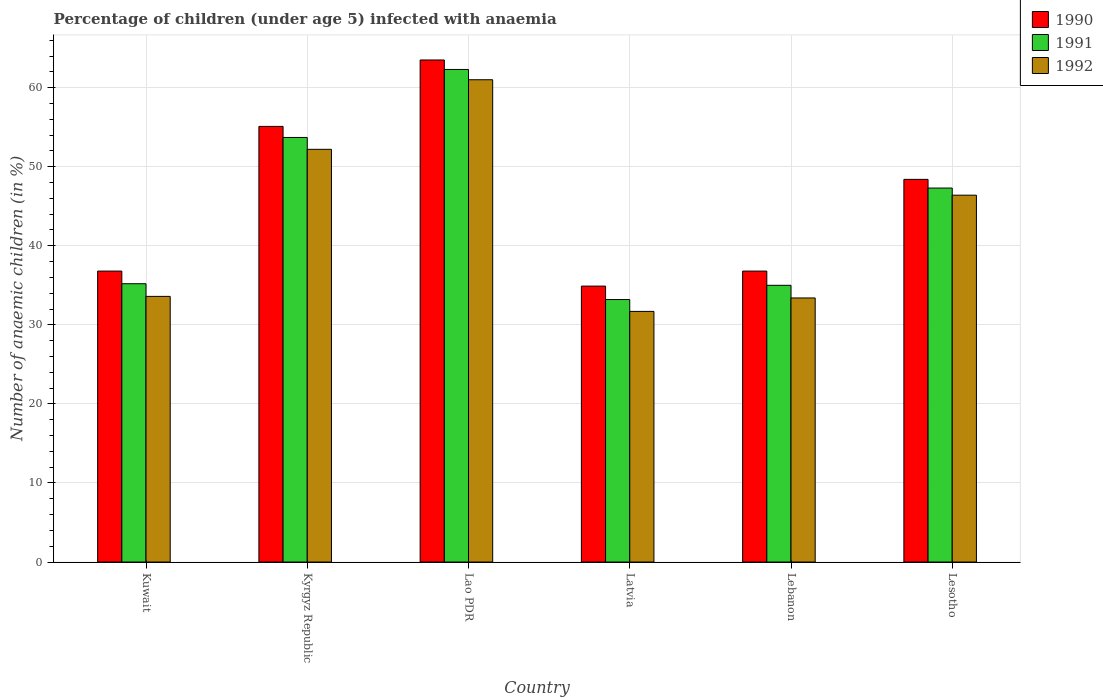Are the number of bars per tick equal to the number of legend labels?
Offer a very short reply. Yes. Are the number of bars on each tick of the X-axis equal?
Offer a terse response. Yes. How many bars are there on the 6th tick from the right?
Your response must be concise. 3. What is the label of the 3rd group of bars from the left?
Make the answer very short. Lao PDR. What is the percentage of children infected with anaemia in in 1991 in Lesotho?
Your response must be concise. 47.3. Across all countries, what is the maximum percentage of children infected with anaemia in in 1991?
Provide a short and direct response. 62.3. Across all countries, what is the minimum percentage of children infected with anaemia in in 1992?
Provide a short and direct response. 31.7. In which country was the percentage of children infected with anaemia in in 1990 maximum?
Keep it short and to the point. Lao PDR. In which country was the percentage of children infected with anaemia in in 1992 minimum?
Offer a very short reply. Latvia. What is the total percentage of children infected with anaemia in in 1990 in the graph?
Keep it short and to the point. 275.5. What is the difference between the percentage of children infected with anaemia in in 1990 in Kuwait and that in Kyrgyz Republic?
Give a very brief answer. -18.3. What is the difference between the percentage of children infected with anaemia in in 1990 in Kyrgyz Republic and the percentage of children infected with anaemia in in 1992 in Lao PDR?
Your response must be concise. -5.9. What is the average percentage of children infected with anaemia in in 1992 per country?
Offer a very short reply. 43.05. What is the difference between the percentage of children infected with anaemia in of/in 1990 and percentage of children infected with anaemia in of/in 1991 in Lao PDR?
Your answer should be compact. 1.2. What is the ratio of the percentage of children infected with anaemia in in 1990 in Kyrgyz Republic to that in Latvia?
Your answer should be very brief. 1.58. Is the percentage of children infected with anaemia in in 1990 in Lebanon less than that in Lesotho?
Provide a succinct answer. Yes. Is the difference between the percentage of children infected with anaemia in in 1990 in Kuwait and Lesotho greater than the difference between the percentage of children infected with anaemia in in 1991 in Kuwait and Lesotho?
Keep it short and to the point. Yes. What is the difference between the highest and the second highest percentage of children infected with anaemia in in 1992?
Provide a succinct answer. -8.8. What is the difference between the highest and the lowest percentage of children infected with anaemia in in 1990?
Make the answer very short. 28.6. What does the 1st bar from the right in Lao PDR represents?
Offer a terse response. 1992. Is it the case that in every country, the sum of the percentage of children infected with anaemia in in 1990 and percentage of children infected with anaemia in in 1991 is greater than the percentage of children infected with anaemia in in 1992?
Make the answer very short. Yes. Are all the bars in the graph horizontal?
Ensure brevity in your answer.  No. How many countries are there in the graph?
Your answer should be compact. 6. What is the difference between two consecutive major ticks on the Y-axis?
Your answer should be compact. 10. How many legend labels are there?
Your answer should be compact. 3. What is the title of the graph?
Keep it short and to the point. Percentage of children (under age 5) infected with anaemia. Does "1960" appear as one of the legend labels in the graph?
Provide a short and direct response. No. What is the label or title of the Y-axis?
Make the answer very short. Number of anaemic children (in %). What is the Number of anaemic children (in %) in 1990 in Kuwait?
Offer a very short reply. 36.8. What is the Number of anaemic children (in %) in 1991 in Kuwait?
Offer a very short reply. 35.2. What is the Number of anaemic children (in %) of 1992 in Kuwait?
Give a very brief answer. 33.6. What is the Number of anaemic children (in %) in 1990 in Kyrgyz Republic?
Make the answer very short. 55.1. What is the Number of anaemic children (in %) of 1991 in Kyrgyz Republic?
Offer a very short reply. 53.7. What is the Number of anaemic children (in %) in 1992 in Kyrgyz Republic?
Ensure brevity in your answer.  52.2. What is the Number of anaemic children (in %) of 1990 in Lao PDR?
Provide a short and direct response. 63.5. What is the Number of anaemic children (in %) in 1991 in Lao PDR?
Offer a very short reply. 62.3. What is the Number of anaemic children (in %) in 1990 in Latvia?
Give a very brief answer. 34.9. What is the Number of anaemic children (in %) of 1991 in Latvia?
Your response must be concise. 33.2. What is the Number of anaemic children (in %) in 1992 in Latvia?
Your answer should be very brief. 31.7. What is the Number of anaemic children (in %) in 1990 in Lebanon?
Ensure brevity in your answer.  36.8. What is the Number of anaemic children (in %) of 1992 in Lebanon?
Ensure brevity in your answer.  33.4. What is the Number of anaemic children (in %) in 1990 in Lesotho?
Your response must be concise. 48.4. What is the Number of anaemic children (in %) in 1991 in Lesotho?
Your response must be concise. 47.3. What is the Number of anaemic children (in %) in 1992 in Lesotho?
Keep it short and to the point. 46.4. Across all countries, what is the maximum Number of anaemic children (in %) of 1990?
Keep it short and to the point. 63.5. Across all countries, what is the maximum Number of anaemic children (in %) of 1991?
Make the answer very short. 62.3. Across all countries, what is the maximum Number of anaemic children (in %) of 1992?
Provide a succinct answer. 61. Across all countries, what is the minimum Number of anaemic children (in %) of 1990?
Provide a succinct answer. 34.9. Across all countries, what is the minimum Number of anaemic children (in %) in 1991?
Offer a very short reply. 33.2. Across all countries, what is the minimum Number of anaemic children (in %) of 1992?
Offer a very short reply. 31.7. What is the total Number of anaemic children (in %) in 1990 in the graph?
Make the answer very short. 275.5. What is the total Number of anaemic children (in %) in 1991 in the graph?
Ensure brevity in your answer.  266.7. What is the total Number of anaemic children (in %) in 1992 in the graph?
Ensure brevity in your answer.  258.3. What is the difference between the Number of anaemic children (in %) in 1990 in Kuwait and that in Kyrgyz Republic?
Give a very brief answer. -18.3. What is the difference between the Number of anaemic children (in %) of 1991 in Kuwait and that in Kyrgyz Republic?
Ensure brevity in your answer.  -18.5. What is the difference between the Number of anaemic children (in %) in 1992 in Kuwait and that in Kyrgyz Republic?
Your answer should be very brief. -18.6. What is the difference between the Number of anaemic children (in %) of 1990 in Kuwait and that in Lao PDR?
Your answer should be very brief. -26.7. What is the difference between the Number of anaemic children (in %) of 1991 in Kuwait and that in Lao PDR?
Provide a succinct answer. -27.1. What is the difference between the Number of anaemic children (in %) in 1992 in Kuwait and that in Lao PDR?
Provide a succinct answer. -27.4. What is the difference between the Number of anaemic children (in %) of 1991 in Kuwait and that in Latvia?
Make the answer very short. 2. What is the difference between the Number of anaemic children (in %) of 1992 in Kuwait and that in Latvia?
Give a very brief answer. 1.9. What is the difference between the Number of anaemic children (in %) of 1990 in Kuwait and that in Lesotho?
Provide a succinct answer. -11.6. What is the difference between the Number of anaemic children (in %) of 1991 in Kyrgyz Republic and that in Lao PDR?
Your response must be concise. -8.6. What is the difference between the Number of anaemic children (in %) in 1992 in Kyrgyz Republic and that in Lao PDR?
Keep it short and to the point. -8.8. What is the difference between the Number of anaemic children (in %) in 1990 in Kyrgyz Republic and that in Latvia?
Give a very brief answer. 20.2. What is the difference between the Number of anaemic children (in %) of 1990 in Kyrgyz Republic and that in Lebanon?
Make the answer very short. 18.3. What is the difference between the Number of anaemic children (in %) in 1991 in Kyrgyz Republic and that in Lebanon?
Your response must be concise. 18.7. What is the difference between the Number of anaemic children (in %) of 1990 in Kyrgyz Republic and that in Lesotho?
Your answer should be very brief. 6.7. What is the difference between the Number of anaemic children (in %) of 1991 in Kyrgyz Republic and that in Lesotho?
Make the answer very short. 6.4. What is the difference between the Number of anaemic children (in %) of 1990 in Lao PDR and that in Latvia?
Your response must be concise. 28.6. What is the difference between the Number of anaemic children (in %) of 1991 in Lao PDR and that in Latvia?
Give a very brief answer. 29.1. What is the difference between the Number of anaemic children (in %) in 1992 in Lao PDR and that in Latvia?
Provide a succinct answer. 29.3. What is the difference between the Number of anaemic children (in %) in 1990 in Lao PDR and that in Lebanon?
Make the answer very short. 26.7. What is the difference between the Number of anaemic children (in %) in 1991 in Lao PDR and that in Lebanon?
Keep it short and to the point. 27.3. What is the difference between the Number of anaemic children (in %) of 1992 in Lao PDR and that in Lebanon?
Provide a short and direct response. 27.6. What is the difference between the Number of anaemic children (in %) of 1990 in Lao PDR and that in Lesotho?
Offer a terse response. 15.1. What is the difference between the Number of anaemic children (in %) in 1991 in Lao PDR and that in Lesotho?
Ensure brevity in your answer.  15. What is the difference between the Number of anaemic children (in %) in 1991 in Latvia and that in Lebanon?
Your response must be concise. -1.8. What is the difference between the Number of anaemic children (in %) in 1991 in Latvia and that in Lesotho?
Your answer should be very brief. -14.1. What is the difference between the Number of anaemic children (in %) in 1992 in Latvia and that in Lesotho?
Provide a succinct answer. -14.7. What is the difference between the Number of anaemic children (in %) in 1990 in Lebanon and that in Lesotho?
Ensure brevity in your answer.  -11.6. What is the difference between the Number of anaemic children (in %) of 1991 in Lebanon and that in Lesotho?
Your answer should be compact. -12.3. What is the difference between the Number of anaemic children (in %) in 1990 in Kuwait and the Number of anaemic children (in %) in 1991 in Kyrgyz Republic?
Offer a very short reply. -16.9. What is the difference between the Number of anaemic children (in %) of 1990 in Kuwait and the Number of anaemic children (in %) of 1992 in Kyrgyz Republic?
Provide a short and direct response. -15.4. What is the difference between the Number of anaemic children (in %) in 1990 in Kuwait and the Number of anaemic children (in %) in 1991 in Lao PDR?
Provide a succinct answer. -25.5. What is the difference between the Number of anaemic children (in %) of 1990 in Kuwait and the Number of anaemic children (in %) of 1992 in Lao PDR?
Offer a terse response. -24.2. What is the difference between the Number of anaemic children (in %) of 1991 in Kuwait and the Number of anaemic children (in %) of 1992 in Lao PDR?
Your answer should be very brief. -25.8. What is the difference between the Number of anaemic children (in %) in 1990 in Kuwait and the Number of anaemic children (in %) in 1991 in Latvia?
Offer a terse response. 3.6. What is the difference between the Number of anaemic children (in %) in 1990 in Kuwait and the Number of anaemic children (in %) in 1992 in Latvia?
Make the answer very short. 5.1. What is the difference between the Number of anaemic children (in %) of 1990 in Kuwait and the Number of anaemic children (in %) of 1991 in Lebanon?
Give a very brief answer. 1.8. What is the difference between the Number of anaemic children (in %) in 1990 in Kuwait and the Number of anaemic children (in %) in 1992 in Lebanon?
Keep it short and to the point. 3.4. What is the difference between the Number of anaemic children (in %) in 1991 in Kuwait and the Number of anaemic children (in %) in 1992 in Lebanon?
Keep it short and to the point. 1.8. What is the difference between the Number of anaemic children (in %) in 1990 in Kuwait and the Number of anaemic children (in %) in 1991 in Lesotho?
Your response must be concise. -10.5. What is the difference between the Number of anaemic children (in %) of 1991 in Kuwait and the Number of anaemic children (in %) of 1992 in Lesotho?
Provide a short and direct response. -11.2. What is the difference between the Number of anaemic children (in %) of 1990 in Kyrgyz Republic and the Number of anaemic children (in %) of 1991 in Latvia?
Make the answer very short. 21.9. What is the difference between the Number of anaemic children (in %) of 1990 in Kyrgyz Republic and the Number of anaemic children (in %) of 1992 in Latvia?
Give a very brief answer. 23.4. What is the difference between the Number of anaemic children (in %) of 1990 in Kyrgyz Republic and the Number of anaemic children (in %) of 1991 in Lebanon?
Your answer should be compact. 20.1. What is the difference between the Number of anaemic children (in %) of 1990 in Kyrgyz Republic and the Number of anaemic children (in %) of 1992 in Lebanon?
Your answer should be compact. 21.7. What is the difference between the Number of anaemic children (in %) of 1991 in Kyrgyz Republic and the Number of anaemic children (in %) of 1992 in Lebanon?
Make the answer very short. 20.3. What is the difference between the Number of anaemic children (in %) of 1990 in Kyrgyz Republic and the Number of anaemic children (in %) of 1992 in Lesotho?
Your response must be concise. 8.7. What is the difference between the Number of anaemic children (in %) in 1990 in Lao PDR and the Number of anaemic children (in %) in 1991 in Latvia?
Offer a very short reply. 30.3. What is the difference between the Number of anaemic children (in %) in 1990 in Lao PDR and the Number of anaemic children (in %) in 1992 in Latvia?
Your response must be concise. 31.8. What is the difference between the Number of anaemic children (in %) in 1991 in Lao PDR and the Number of anaemic children (in %) in 1992 in Latvia?
Make the answer very short. 30.6. What is the difference between the Number of anaemic children (in %) of 1990 in Lao PDR and the Number of anaemic children (in %) of 1991 in Lebanon?
Give a very brief answer. 28.5. What is the difference between the Number of anaemic children (in %) of 1990 in Lao PDR and the Number of anaemic children (in %) of 1992 in Lebanon?
Provide a succinct answer. 30.1. What is the difference between the Number of anaemic children (in %) in 1991 in Lao PDR and the Number of anaemic children (in %) in 1992 in Lebanon?
Provide a short and direct response. 28.9. What is the difference between the Number of anaemic children (in %) in 1991 in Latvia and the Number of anaemic children (in %) in 1992 in Lebanon?
Provide a short and direct response. -0.2. What is the difference between the Number of anaemic children (in %) of 1990 in Latvia and the Number of anaemic children (in %) of 1991 in Lesotho?
Keep it short and to the point. -12.4. What is the difference between the Number of anaemic children (in %) of 1991 in Latvia and the Number of anaemic children (in %) of 1992 in Lesotho?
Give a very brief answer. -13.2. What is the difference between the Number of anaemic children (in %) in 1990 in Lebanon and the Number of anaemic children (in %) in 1991 in Lesotho?
Give a very brief answer. -10.5. What is the difference between the Number of anaemic children (in %) in 1990 in Lebanon and the Number of anaemic children (in %) in 1992 in Lesotho?
Your response must be concise. -9.6. What is the difference between the Number of anaemic children (in %) of 1991 in Lebanon and the Number of anaemic children (in %) of 1992 in Lesotho?
Offer a very short reply. -11.4. What is the average Number of anaemic children (in %) of 1990 per country?
Your answer should be compact. 45.92. What is the average Number of anaemic children (in %) of 1991 per country?
Your answer should be very brief. 44.45. What is the average Number of anaemic children (in %) of 1992 per country?
Provide a succinct answer. 43.05. What is the difference between the Number of anaemic children (in %) of 1990 and Number of anaemic children (in %) of 1991 in Kuwait?
Keep it short and to the point. 1.6. What is the difference between the Number of anaemic children (in %) in 1990 and Number of anaemic children (in %) in 1992 in Kuwait?
Offer a terse response. 3.2. What is the difference between the Number of anaemic children (in %) of 1990 and Number of anaemic children (in %) of 1991 in Kyrgyz Republic?
Ensure brevity in your answer.  1.4. What is the difference between the Number of anaemic children (in %) in 1991 and Number of anaemic children (in %) in 1992 in Kyrgyz Republic?
Make the answer very short. 1.5. What is the difference between the Number of anaemic children (in %) in 1990 and Number of anaemic children (in %) in 1991 in Lao PDR?
Offer a very short reply. 1.2. What is the difference between the Number of anaemic children (in %) in 1991 and Number of anaemic children (in %) in 1992 in Lao PDR?
Your answer should be compact. 1.3. What is the difference between the Number of anaemic children (in %) of 1990 and Number of anaemic children (in %) of 1991 in Latvia?
Keep it short and to the point. 1.7. What is the difference between the Number of anaemic children (in %) of 1991 and Number of anaemic children (in %) of 1992 in Lebanon?
Keep it short and to the point. 1.6. What is the difference between the Number of anaemic children (in %) in 1990 and Number of anaemic children (in %) in 1991 in Lesotho?
Provide a succinct answer. 1.1. What is the ratio of the Number of anaemic children (in %) in 1990 in Kuwait to that in Kyrgyz Republic?
Your answer should be very brief. 0.67. What is the ratio of the Number of anaemic children (in %) of 1991 in Kuwait to that in Kyrgyz Republic?
Your answer should be compact. 0.66. What is the ratio of the Number of anaemic children (in %) of 1992 in Kuwait to that in Kyrgyz Republic?
Offer a terse response. 0.64. What is the ratio of the Number of anaemic children (in %) of 1990 in Kuwait to that in Lao PDR?
Offer a very short reply. 0.58. What is the ratio of the Number of anaemic children (in %) of 1991 in Kuwait to that in Lao PDR?
Offer a very short reply. 0.56. What is the ratio of the Number of anaemic children (in %) of 1992 in Kuwait to that in Lao PDR?
Your response must be concise. 0.55. What is the ratio of the Number of anaemic children (in %) in 1990 in Kuwait to that in Latvia?
Offer a terse response. 1.05. What is the ratio of the Number of anaemic children (in %) of 1991 in Kuwait to that in Latvia?
Your answer should be compact. 1.06. What is the ratio of the Number of anaemic children (in %) of 1992 in Kuwait to that in Latvia?
Offer a very short reply. 1.06. What is the ratio of the Number of anaemic children (in %) of 1990 in Kuwait to that in Lebanon?
Offer a terse response. 1. What is the ratio of the Number of anaemic children (in %) in 1991 in Kuwait to that in Lebanon?
Provide a short and direct response. 1.01. What is the ratio of the Number of anaemic children (in %) in 1990 in Kuwait to that in Lesotho?
Keep it short and to the point. 0.76. What is the ratio of the Number of anaemic children (in %) in 1991 in Kuwait to that in Lesotho?
Offer a terse response. 0.74. What is the ratio of the Number of anaemic children (in %) in 1992 in Kuwait to that in Lesotho?
Ensure brevity in your answer.  0.72. What is the ratio of the Number of anaemic children (in %) in 1990 in Kyrgyz Republic to that in Lao PDR?
Your answer should be compact. 0.87. What is the ratio of the Number of anaemic children (in %) of 1991 in Kyrgyz Republic to that in Lao PDR?
Offer a terse response. 0.86. What is the ratio of the Number of anaemic children (in %) in 1992 in Kyrgyz Republic to that in Lao PDR?
Your response must be concise. 0.86. What is the ratio of the Number of anaemic children (in %) in 1990 in Kyrgyz Republic to that in Latvia?
Offer a terse response. 1.58. What is the ratio of the Number of anaemic children (in %) in 1991 in Kyrgyz Republic to that in Latvia?
Your answer should be very brief. 1.62. What is the ratio of the Number of anaemic children (in %) in 1992 in Kyrgyz Republic to that in Latvia?
Offer a terse response. 1.65. What is the ratio of the Number of anaemic children (in %) of 1990 in Kyrgyz Republic to that in Lebanon?
Give a very brief answer. 1.5. What is the ratio of the Number of anaemic children (in %) of 1991 in Kyrgyz Republic to that in Lebanon?
Offer a terse response. 1.53. What is the ratio of the Number of anaemic children (in %) in 1992 in Kyrgyz Republic to that in Lebanon?
Provide a short and direct response. 1.56. What is the ratio of the Number of anaemic children (in %) in 1990 in Kyrgyz Republic to that in Lesotho?
Ensure brevity in your answer.  1.14. What is the ratio of the Number of anaemic children (in %) in 1991 in Kyrgyz Republic to that in Lesotho?
Make the answer very short. 1.14. What is the ratio of the Number of anaemic children (in %) in 1990 in Lao PDR to that in Latvia?
Provide a short and direct response. 1.82. What is the ratio of the Number of anaemic children (in %) in 1991 in Lao PDR to that in Latvia?
Your answer should be compact. 1.88. What is the ratio of the Number of anaemic children (in %) of 1992 in Lao PDR to that in Latvia?
Provide a short and direct response. 1.92. What is the ratio of the Number of anaemic children (in %) in 1990 in Lao PDR to that in Lebanon?
Give a very brief answer. 1.73. What is the ratio of the Number of anaemic children (in %) in 1991 in Lao PDR to that in Lebanon?
Ensure brevity in your answer.  1.78. What is the ratio of the Number of anaemic children (in %) in 1992 in Lao PDR to that in Lebanon?
Provide a short and direct response. 1.83. What is the ratio of the Number of anaemic children (in %) in 1990 in Lao PDR to that in Lesotho?
Provide a succinct answer. 1.31. What is the ratio of the Number of anaemic children (in %) of 1991 in Lao PDR to that in Lesotho?
Offer a very short reply. 1.32. What is the ratio of the Number of anaemic children (in %) of 1992 in Lao PDR to that in Lesotho?
Your response must be concise. 1.31. What is the ratio of the Number of anaemic children (in %) of 1990 in Latvia to that in Lebanon?
Your answer should be very brief. 0.95. What is the ratio of the Number of anaemic children (in %) in 1991 in Latvia to that in Lebanon?
Provide a short and direct response. 0.95. What is the ratio of the Number of anaemic children (in %) of 1992 in Latvia to that in Lebanon?
Keep it short and to the point. 0.95. What is the ratio of the Number of anaemic children (in %) in 1990 in Latvia to that in Lesotho?
Your answer should be very brief. 0.72. What is the ratio of the Number of anaemic children (in %) in 1991 in Latvia to that in Lesotho?
Offer a terse response. 0.7. What is the ratio of the Number of anaemic children (in %) of 1992 in Latvia to that in Lesotho?
Your answer should be very brief. 0.68. What is the ratio of the Number of anaemic children (in %) of 1990 in Lebanon to that in Lesotho?
Provide a short and direct response. 0.76. What is the ratio of the Number of anaemic children (in %) in 1991 in Lebanon to that in Lesotho?
Provide a short and direct response. 0.74. What is the ratio of the Number of anaemic children (in %) in 1992 in Lebanon to that in Lesotho?
Offer a very short reply. 0.72. What is the difference between the highest and the second highest Number of anaemic children (in %) in 1990?
Your answer should be very brief. 8.4. What is the difference between the highest and the second highest Number of anaemic children (in %) in 1991?
Offer a terse response. 8.6. What is the difference between the highest and the lowest Number of anaemic children (in %) in 1990?
Give a very brief answer. 28.6. What is the difference between the highest and the lowest Number of anaemic children (in %) in 1991?
Your answer should be compact. 29.1. What is the difference between the highest and the lowest Number of anaemic children (in %) of 1992?
Give a very brief answer. 29.3. 